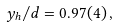<formula> <loc_0><loc_0><loc_500><loc_500>y _ { h } / d = 0 . 9 7 ( 4 ) \, ,</formula> 